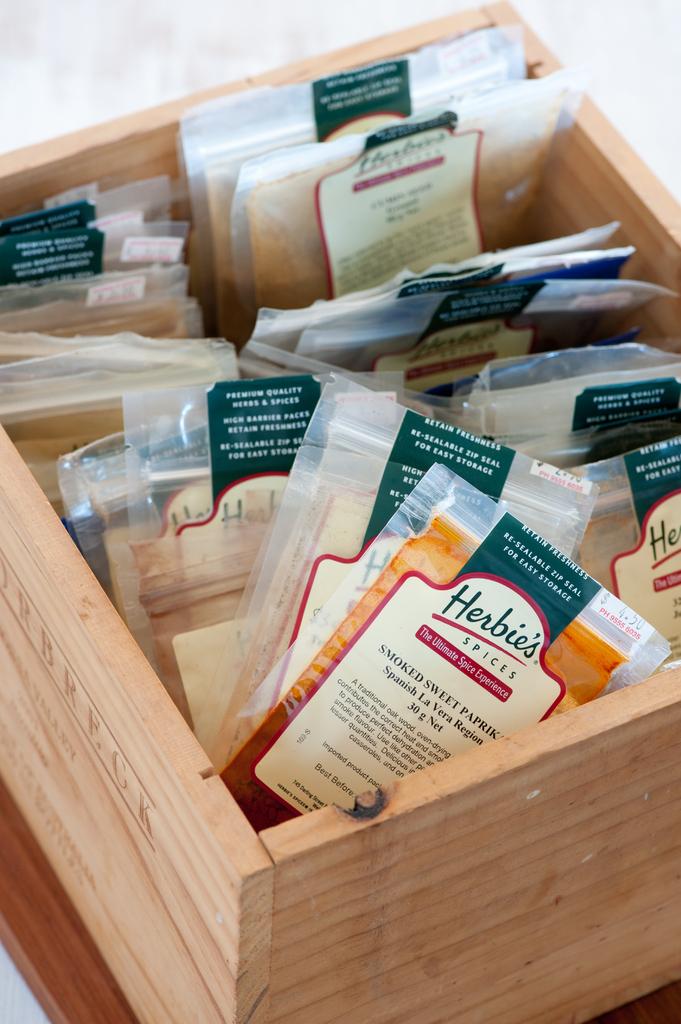What brand is the packets?
Your answer should be compact. Herbies. 